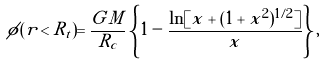<formula> <loc_0><loc_0><loc_500><loc_500>\phi ( r < R _ { t } ) = \frac { G \tilde { M } } { R _ { c } } \left \{ 1 - \frac { \ln [ x + ( 1 + x ^ { 2 } ) ^ { 1 / 2 } ] } { x } \right \} ,</formula> 